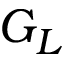Convert formula to latex. <formula><loc_0><loc_0><loc_500><loc_500>G _ { L }</formula> 